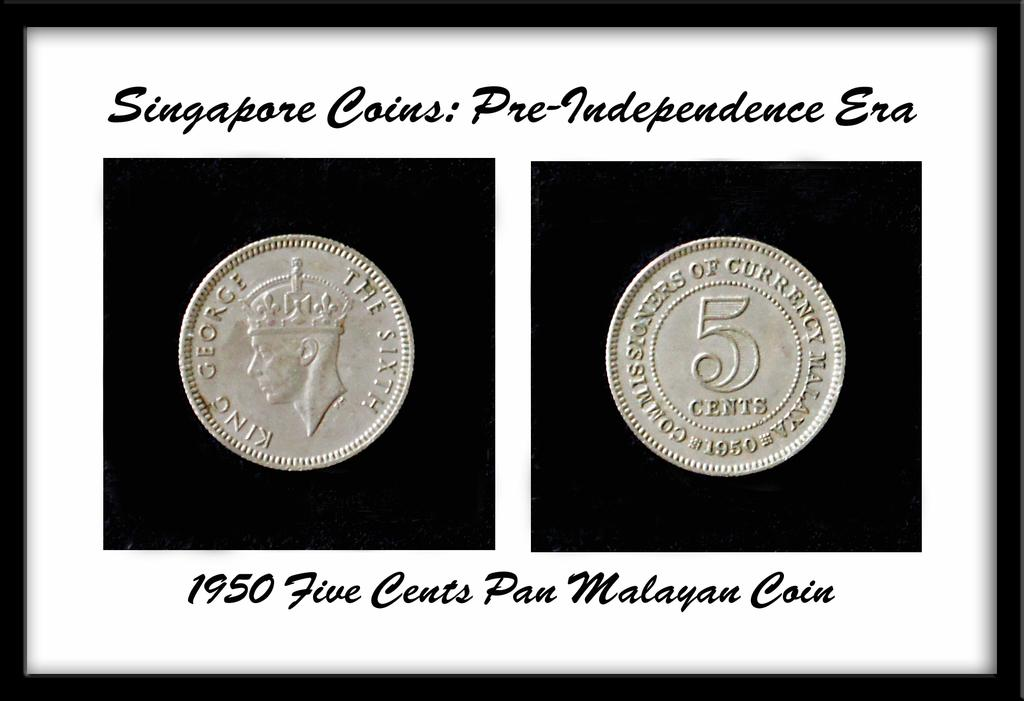<image>
Share a concise interpretation of the image provided. Two silver Singapore Coins from the Pre-Independence Era. 